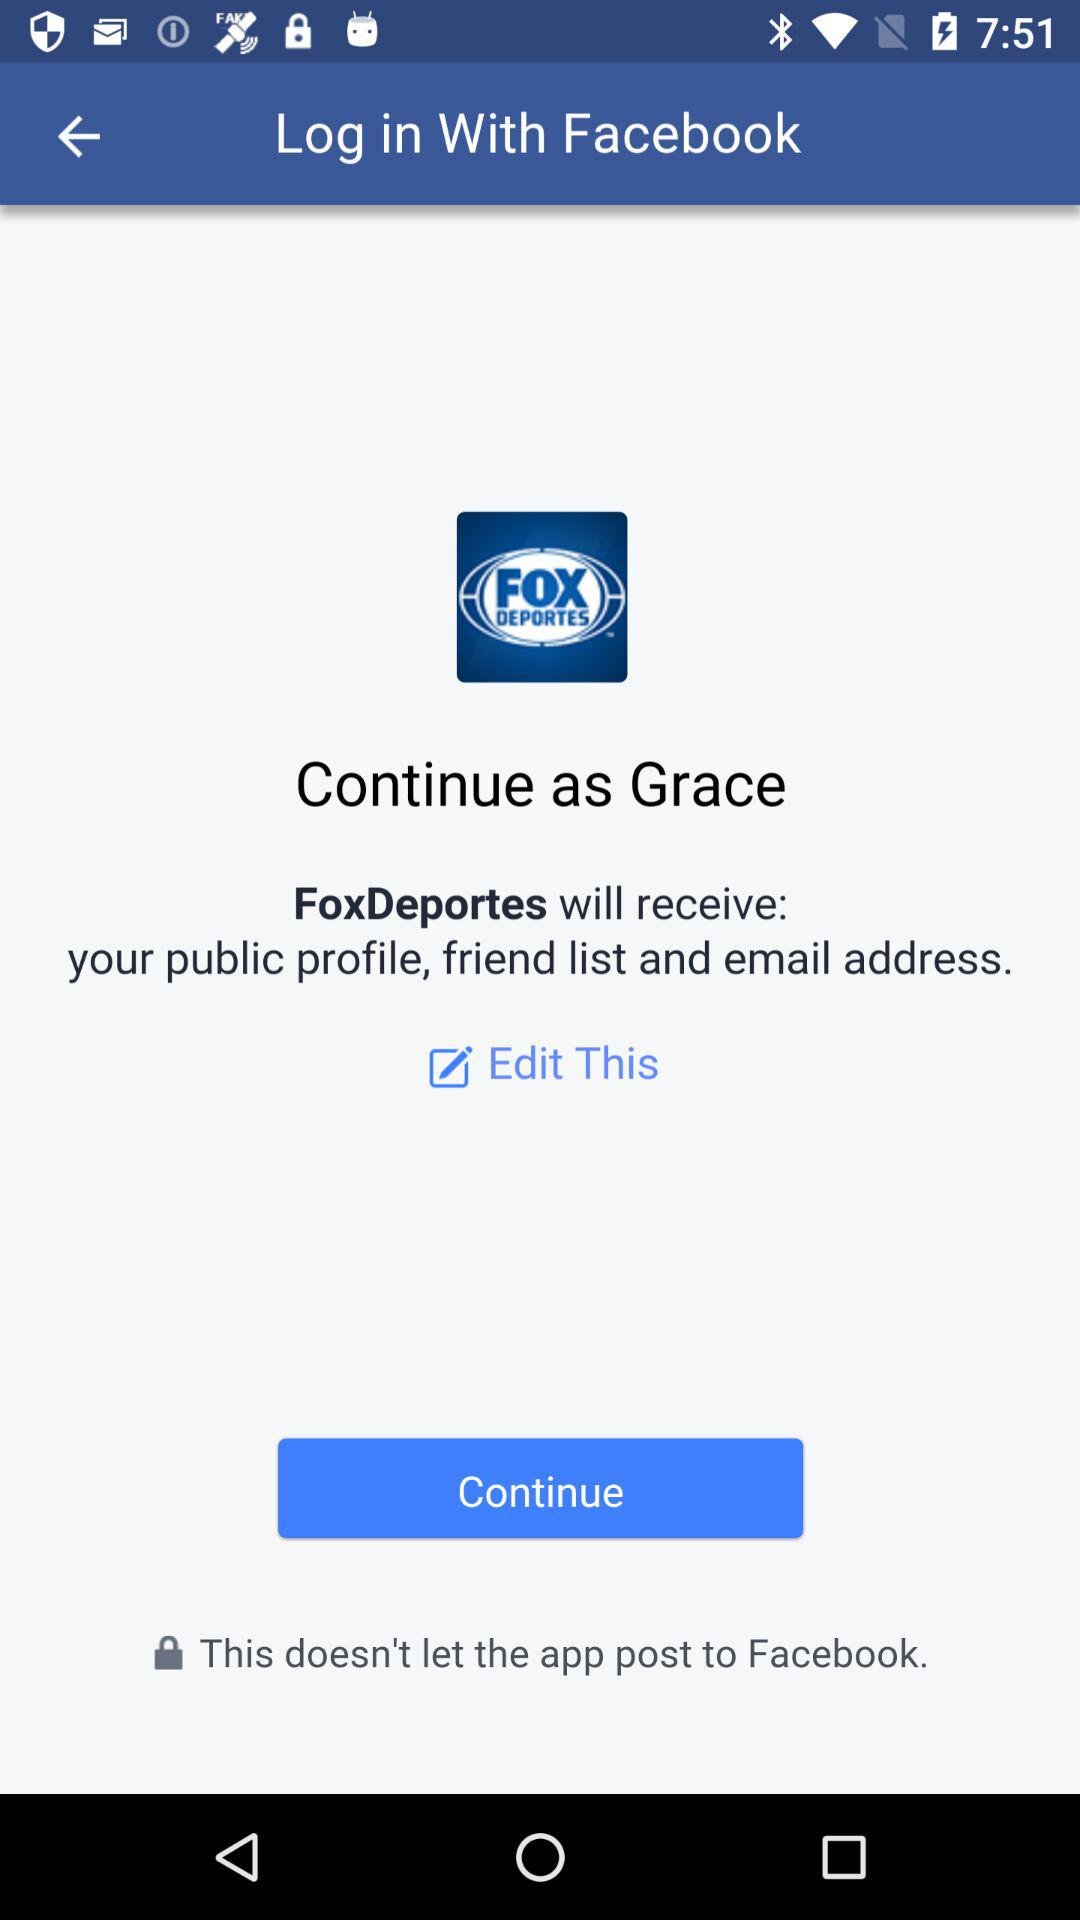How can we log in? You can log in with "Facebook". 